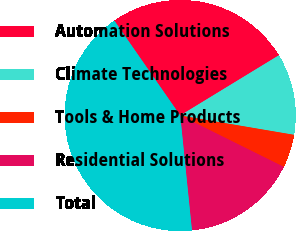Convert chart to OTSL. <chart><loc_0><loc_0><loc_500><loc_500><pie_chart><fcel>Automation Solutions<fcel>Climate Technologies<fcel>Tools & Home Products<fcel>Residential Solutions<fcel>Total<nl><fcel>25.94%<fcel>11.4%<fcel>4.65%<fcel>16.05%<fcel>41.96%<nl></chart> 